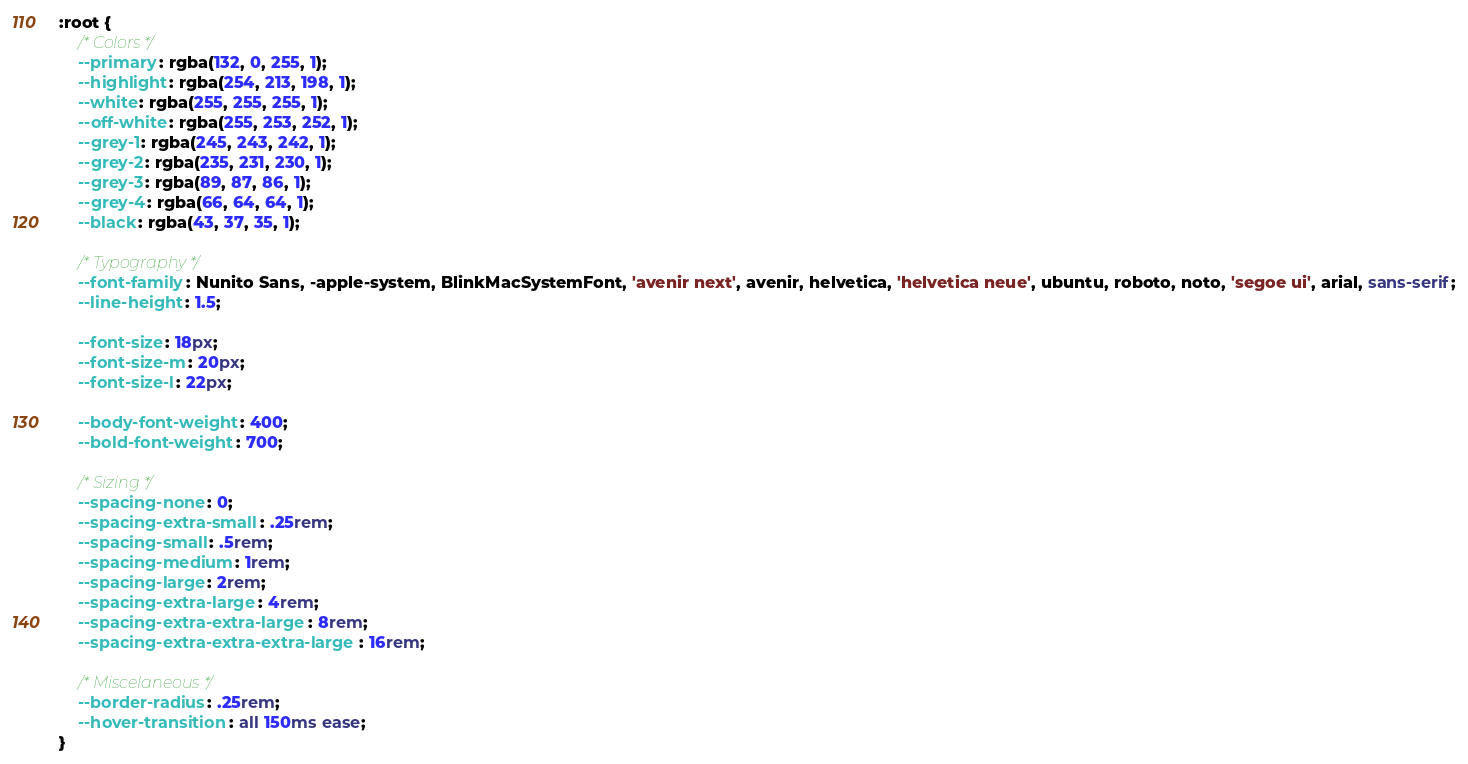Convert code to text. <code><loc_0><loc_0><loc_500><loc_500><_CSS_>:root {
	/* Colors */
	--primary: rgba(132, 0, 255, 1);
	--highlight: rgba(254, 213, 198, 1);
	--white: rgba(255, 255, 255, 1);
	--off-white: rgba(255, 253, 252, 1);
	--grey-1: rgba(245, 243, 242, 1);
	--grey-2: rgba(235, 231, 230, 1);
	--grey-3: rgba(89, 87, 86, 1);
	--grey-4: rgba(66, 64, 64, 1);
	--black: rgba(43, 37, 35, 1);

	/* Typography */
	--font-family: Nunito Sans, -apple-system, BlinkMacSystemFont, 'avenir next', avenir, helvetica, 'helvetica neue', ubuntu, roboto, noto, 'segoe ui', arial, sans-serif;
	--line-height: 1.5;

	--font-size: 18px;
	--font-size-m: 20px;
	--font-size-l: 22px;

	--body-font-weight: 400;
	--bold-font-weight: 700;

	/* Sizing */
	--spacing-none: 0;
	--spacing-extra-small: .25rem;
	--spacing-small: .5rem;
	--spacing-medium: 1rem;
	--spacing-large: 2rem;
	--spacing-extra-large: 4rem;
	--spacing-extra-extra-large: 8rem;
	--spacing-extra-extra-extra-large: 16rem;

	/* Miscelaneous */
	--border-radius: .25rem;
	--hover-transition: all 150ms ease;
}
</code> 